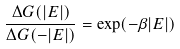Convert formula to latex. <formula><loc_0><loc_0><loc_500><loc_500>\frac { \Delta G ( | E | ) } { \Delta G ( - | E | ) } = \exp ( - \beta | E | )</formula> 